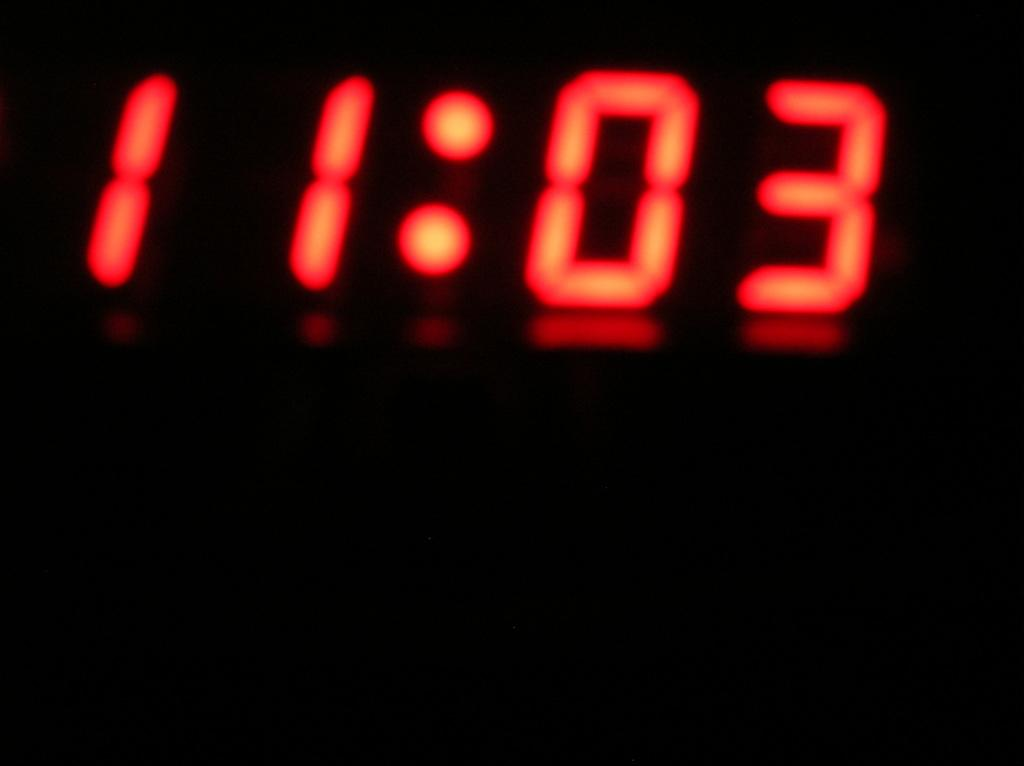<image>
Give a short and clear explanation of the subsequent image. A clock reads the time of 11:03 in red numbers. 